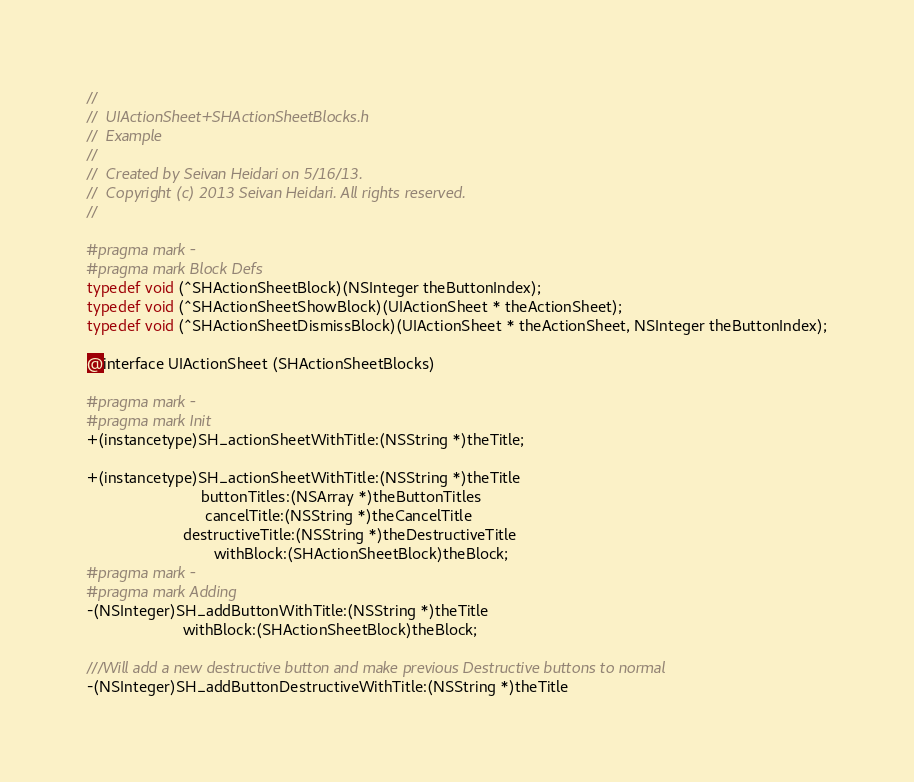Convert code to text. <code><loc_0><loc_0><loc_500><loc_500><_C_>//
//  UIActionSheet+SHActionSheetBlocks.h
//  Example
//
//  Created by Seivan Heidari on 5/16/13.
//  Copyright (c) 2013 Seivan Heidari. All rights reserved.
//

#pragma mark -
#pragma mark Block Defs
typedef void (^SHActionSheetBlock)(NSInteger theButtonIndex);
typedef void (^SHActionSheetShowBlock)(UIActionSheet * theActionSheet);
typedef void (^SHActionSheetDismissBlock)(UIActionSheet * theActionSheet, NSInteger theButtonIndex);

@interface UIActionSheet (SHActionSheetBlocks)

#pragma mark -
#pragma mark Init
+(instancetype)SH_actionSheetWithTitle:(NSString *)theTitle;

+(instancetype)SH_actionSheetWithTitle:(NSString *)theTitle
                          buttonTitles:(NSArray *)theButtonTitles
                           cancelTitle:(NSString *)theCancelTitle
                      destructiveTitle:(NSString *)theDestructiveTitle
                             withBlock:(SHActionSheetBlock)theBlock;
#pragma mark -
#pragma mark Adding
-(NSInteger)SH_addButtonWithTitle:(NSString *)theTitle
                      withBlock:(SHActionSheetBlock)theBlock;

///Will add a new destructive button and make previous Destructive buttons to normal
-(NSInteger)SH_addButtonDestructiveWithTitle:(NSString *)theTitle</code> 